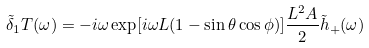Convert formula to latex. <formula><loc_0><loc_0><loc_500><loc_500>\tilde { \delta } _ { 1 } T ( \omega ) = - i \omega \exp [ i \omega L ( 1 - \sin \theta \cos \phi ) ] \frac { L ^ { 2 } A } { 2 } \tilde { h } _ { + } ( \omega )</formula> 